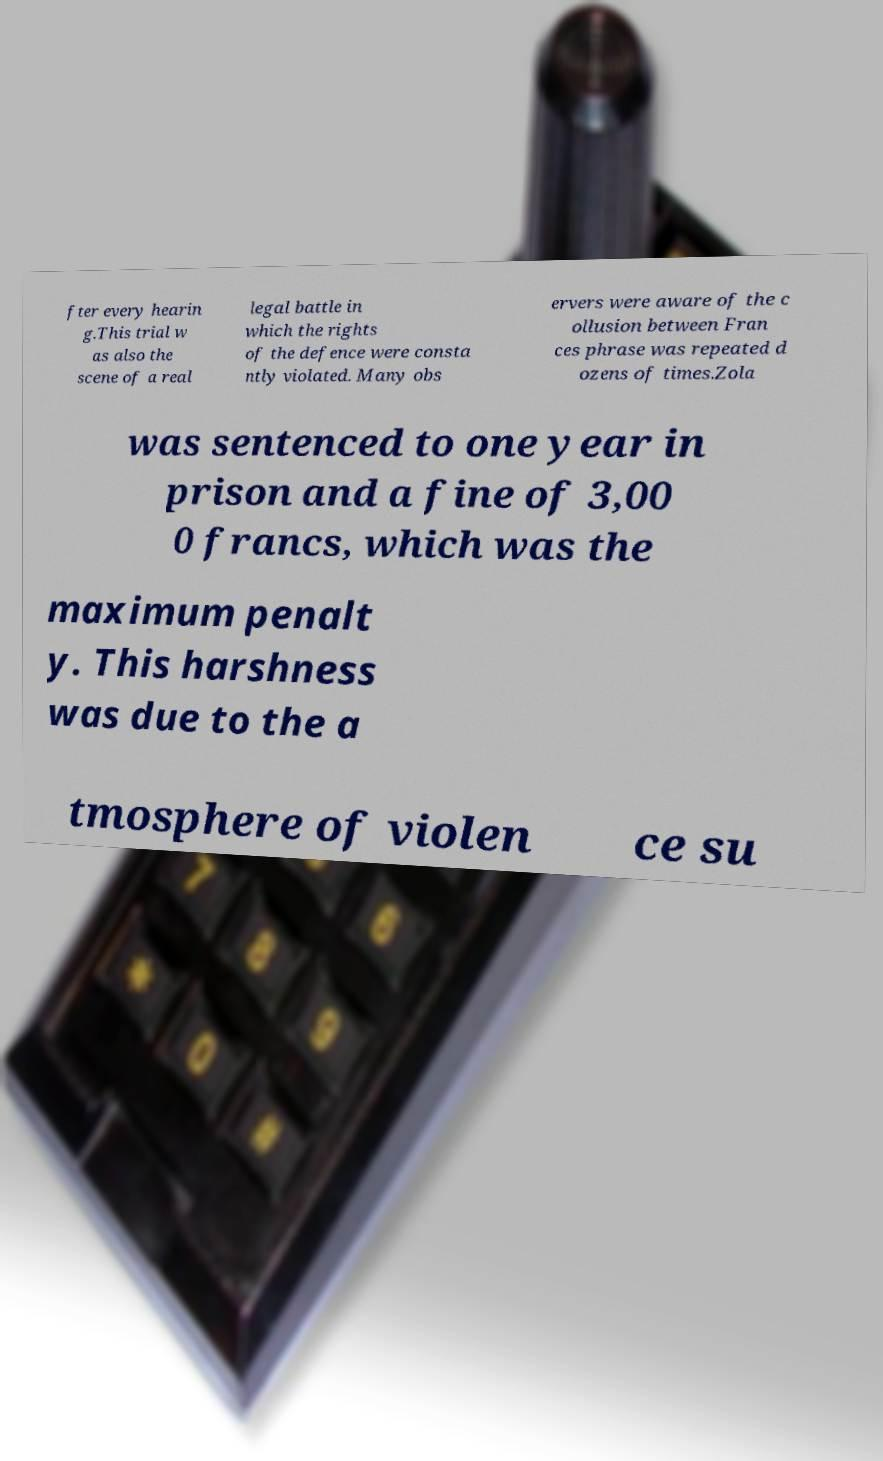There's text embedded in this image that I need extracted. Can you transcribe it verbatim? fter every hearin g.This trial w as also the scene of a real legal battle in which the rights of the defence were consta ntly violated. Many obs ervers were aware of the c ollusion between Fran ces phrase was repeated d ozens of times.Zola was sentenced to one year in prison and a fine of 3,00 0 francs, which was the maximum penalt y. This harshness was due to the a tmosphere of violen ce su 